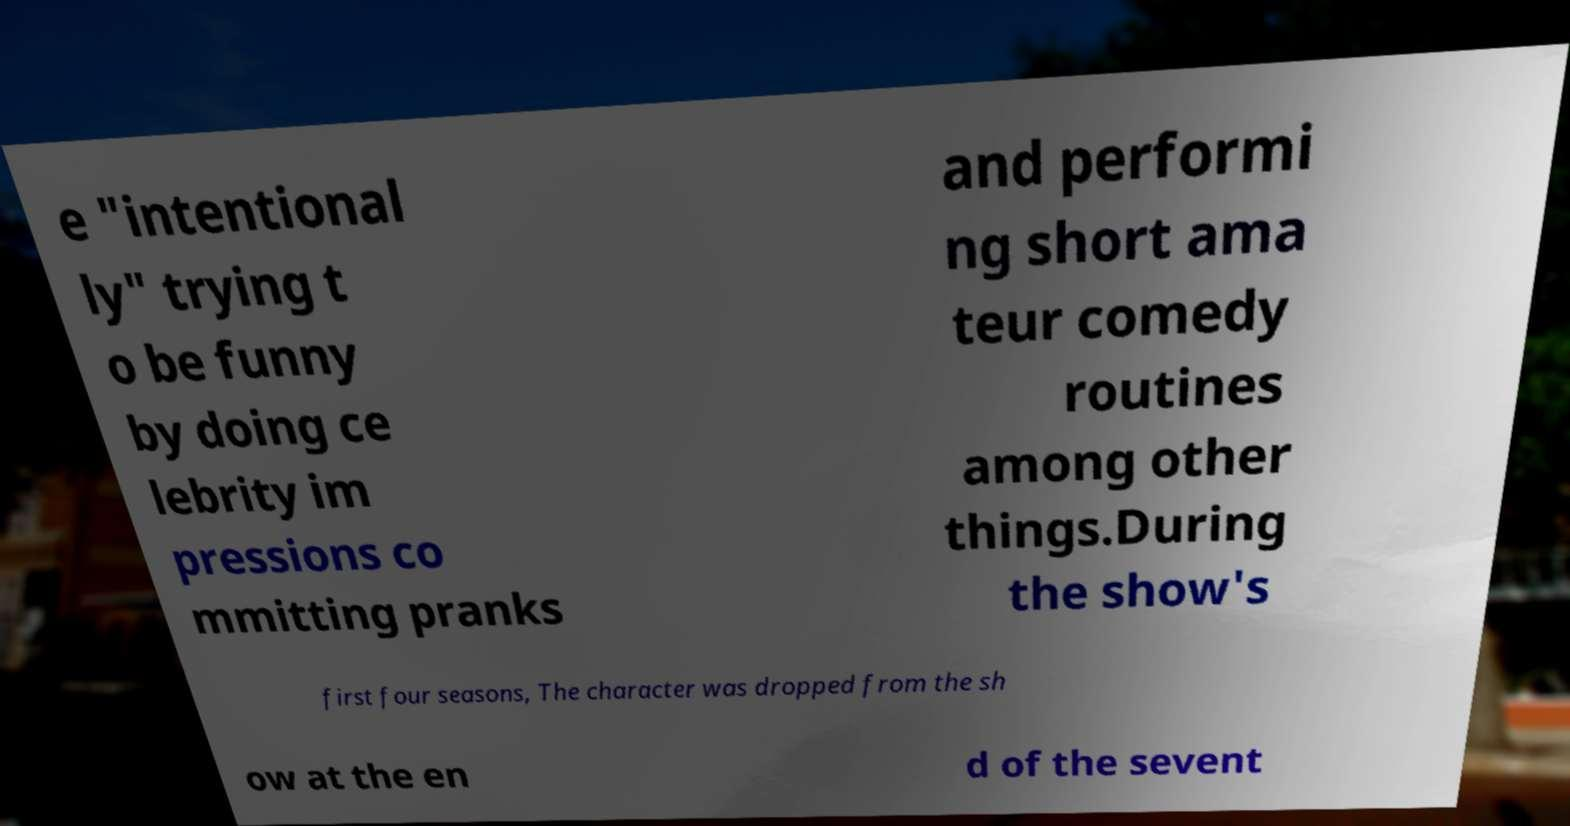Please read and relay the text visible in this image. What does it say? e "intentional ly" trying t o be funny by doing ce lebrity im pressions co mmitting pranks and performi ng short ama teur comedy routines among other things.During the show's first four seasons, The character was dropped from the sh ow at the en d of the sevent 